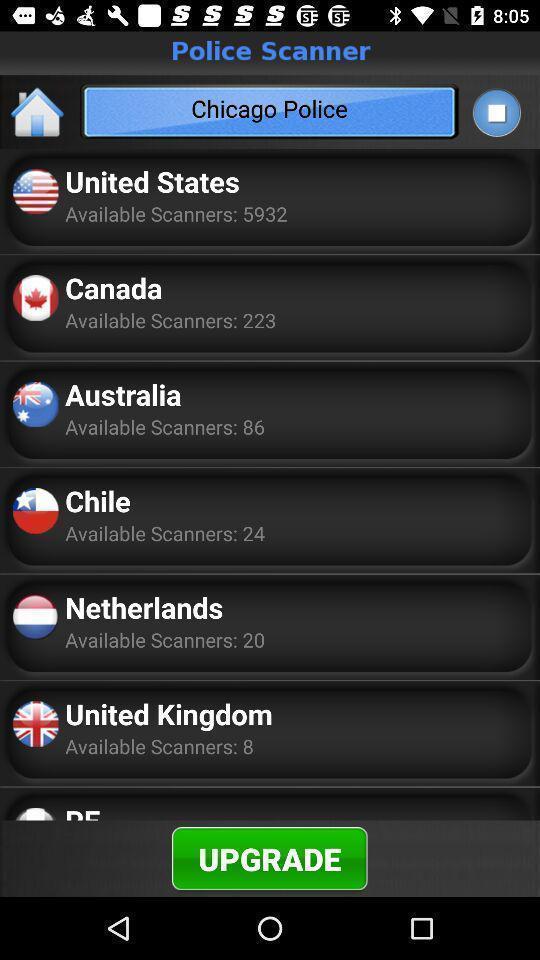Describe the visual elements of this screenshot. Page with different countries with details and a option. 